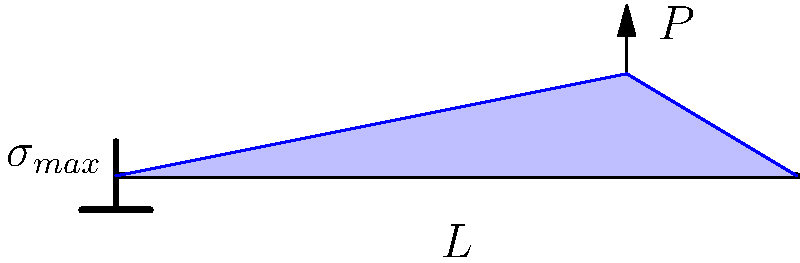In a cantilever beam subjected to a point load $P$ at its free end, how does the bending stress distribution vary along the length of the beam? Consider the implications this might have on structural integrity reporting in engineering journalism. To understand the bending stress distribution in a cantilever beam under a point load, let's break it down step-by-step:

1. Beam configuration: The cantilever beam is fixed at one end and free at the other, with length $L$. The point load $P$ is applied at the free end.

2. Bending moment: The bending moment $M$ varies linearly along the beam's length. It's maximum at the fixed end and zero at the free end.
   $M(x) = P(L-x)$, where $x$ is the distance from the fixed end.

3. Stress-moment relationship: The bending stress $\sigma$ at any point in the beam is related to the bending moment by the flexure formula:
   $\sigma = \frac{My}{I}$
   Where $y$ is the distance from the neutral axis, and $I$ is the moment of inertia of the cross-section.

4. Stress distribution:
   a) Along the length: The stress varies linearly from maximum at the fixed end to zero at the free end, following the bending moment distribution.
   b) Across the cross-section: At any given cross-section, the stress varies linearly from maximum tension at the top surface to maximum compression at the bottom surface (or vice versa, depending on the load direction).

5. Maximum stress: The maximum stress occurs at the fixed end, at the outermost fibers of the cross-section.
   $\sigma_{max} = \frac{PL\cdot c}{I}$
   Where $c$ is the distance from the neutral axis to the outermost fiber.

6. Journalistic implications: Understanding this stress distribution is crucial for reporting on structural integrity. It highlights why failures in cantilever structures often originate at the fixed end, and why engineers focus on reinforcing this area. This knowledge can inform more accurate and insightful reporting on engineering failures or innovations in structural design.
Answer: Linear variation; maximum at fixed end, zero at free end. 